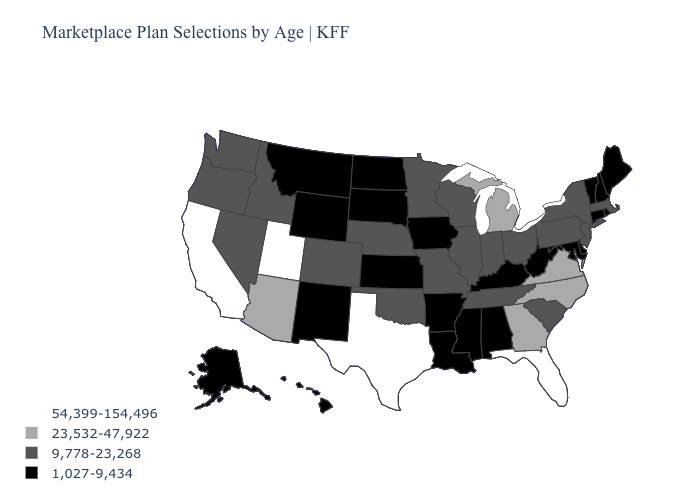Name the states that have a value in the range 54,399-154,496?
Quick response, please. California, Florida, Texas, Utah. What is the value of Missouri?
Keep it brief. 9,778-23,268. Does South Dakota have the lowest value in the USA?
Quick response, please. Yes. Name the states that have a value in the range 54,399-154,496?
Be succinct. California, Florida, Texas, Utah. Does Texas have the highest value in the USA?
Short answer required. Yes. What is the highest value in the West ?
Answer briefly. 54,399-154,496. What is the value of Connecticut?
Keep it brief. 1,027-9,434. Does New York have a higher value than Illinois?
Write a very short answer. No. Which states have the highest value in the USA?
Give a very brief answer. California, Florida, Texas, Utah. What is the value of New Mexico?
Keep it brief. 1,027-9,434. Name the states that have a value in the range 23,532-47,922?
Quick response, please. Arizona, Georgia, Michigan, North Carolina, Virginia. Which states have the lowest value in the Northeast?
Give a very brief answer. Connecticut, Maine, New Hampshire, Rhode Island, Vermont. Does Kansas have the same value as Maine?
Give a very brief answer. Yes. Does Massachusetts have the highest value in the Northeast?
Keep it brief. Yes. What is the value of Missouri?
Answer briefly. 9,778-23,268. 